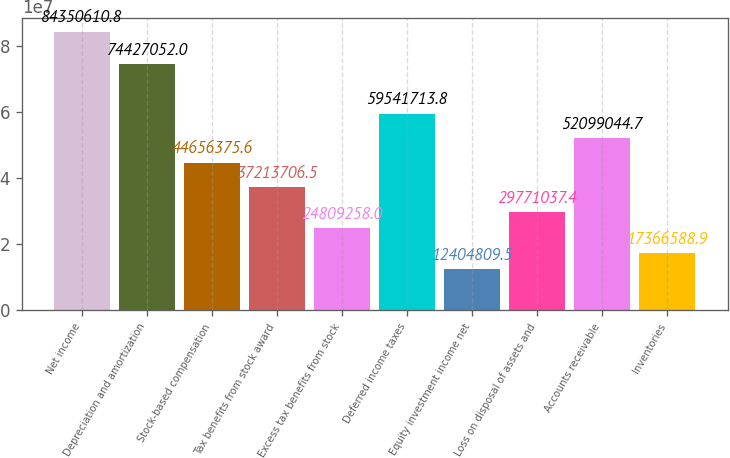Convert chart to OTSL. <chart><loc_0><loc_0><loc_500><loc_500><bar_chart><fcel>Net income<fcel>Depreciation and amortization<fcel>Stock-based compensation<fcel>Tax benefits from stock award<fcel>Excess tax benefits from stock<fcel>Deferred income taxes<fcel>Equity investment income net<fcel>Loss on disposal of assets and<fcel>Accounts receivable<fcel>Inventories<nl><fcel>8.43506e+07<fcel>7.44271e+07<fcel>4.46564e+07<fcel>3.72137e+07<fcel>2.48093e+07<fcel>5.95417e+07<fcel>1.24048e+07<fcel>2.9771e+07<fcel>5.2099e+07<fcel>1.73666e+07<nl></chart> 